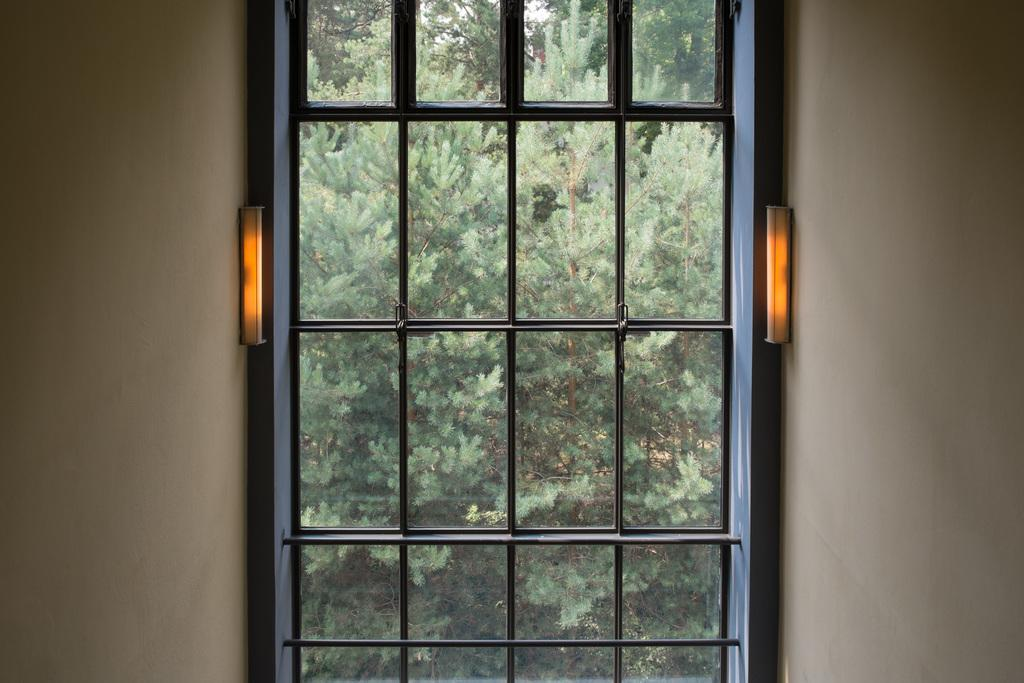What type of vegetation can be seen in the image? There is a group of trees visible in the image. How are the trees being viewed in the image? The trees are seen through a glass window. What type of artificial lighting is present in the image? There are lights on the walls in the image. What type of bubble can be seen floating near the trees in the image? There is no bubble present in the image; it only features a group of trees seen through a glass window and lights on the walls. 